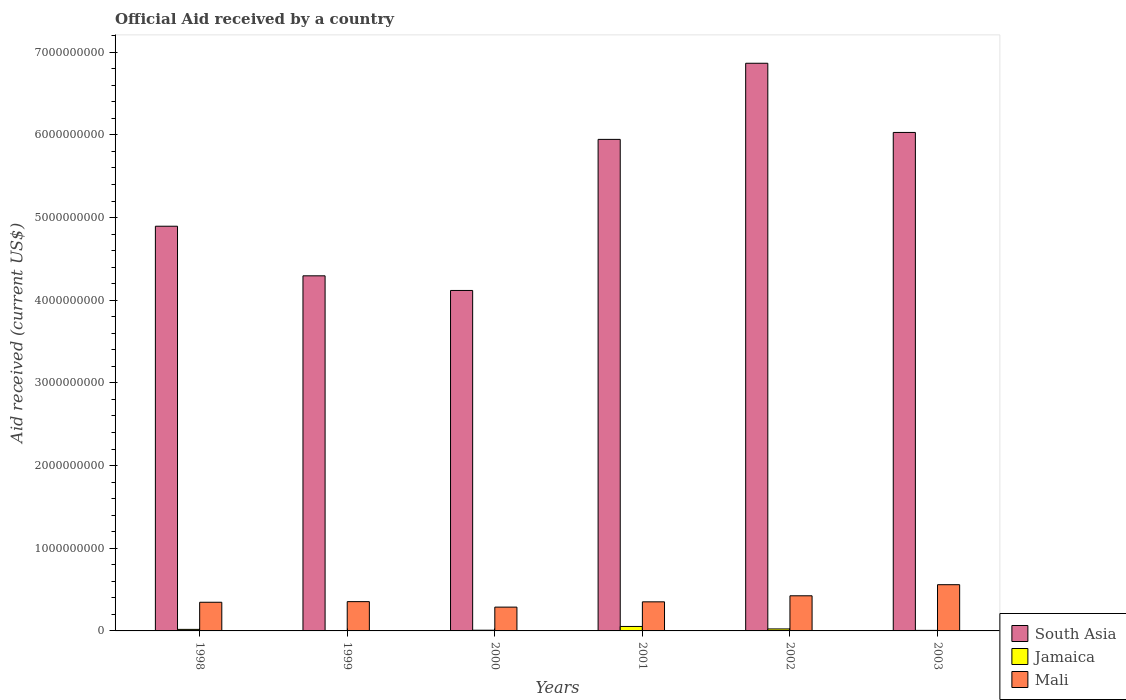How many different coloured bars are there?
Offer a very short reply. 3. Are the number of bars per tick equal to the number of legend labels?
Offer a terse response. No. Are the number of bars on each tick of the X-axis equal?
Provide a succinct answer. No. What is the net official aid received in Jamaica in 2003?
Your response must be concise. 6.52e+06. Across all years, what is the maximum net official aid received in South Asia?
Provide a succinct answer. 6.87e+09. Across all years, what is the minimum net official aid received in Mali?
Make the answer very short. 2.88e+08. In which year was the net official aid received in Mali maximum?
Make the answer very short. 2003. What is the total net official aid received in Mali in the graph?
Ensure brevity in your answer.  2.32e+09. What is the difference between the net official aid received in Jamaica in 1998 and that in 2002?
Give a very brief answer. -5.45e+06. What is the difference between the net official aid received in Jamaica in 1998 and the net official aid received in South Asia in 2002?
Provide a short and direct response. -6.85e+09. What is the average net official aid received in South Asia per year?
Your answer should be very brief. 5.36e+09. In the year 2002, what is the difference between the net official aid received in Mali and net official aid received in Jamaica?
Ensure brevity in your answer.  4.01e+08. What is the ratio of the net official aid received in South Asia in 1998 to that in 1999?
Offer a very short reply. 1.14. Is the net official aid received in South Asia in 2001 less than that in 2002?
Ensure brevity in your answer.  Yes. What is the difference between the highest and the second highest net official aid received in South Asia?
Offer a terse response. 8.37e+08. What is the difference between the highest and the lowest net official aid received in South Asia?
Give a very brief answer. 2.75e+09. In how many years, is the net official aid received in South Asia greater than the average net official aid received in South Asia taken over all years?
Ensure brevity in your answer.  3. Are the values on the major ticks of Y-axis written in scientific E-notation?
Give a very brief answer. No. Does the graph contain any zero values?
Make the answer very short. Yes. Does the graph contain grids?
Make the answer very short. No. What is the title of the graph?
Provide a short and direct response. Official Aid received by a country. Does "Equatorial Guinea" appear as one of the legend labels in the graph?
Offer a very short reply. No. What is the label or title of the X-axis?
Provide a succinct answer. Years. What is the label or title of the Y-axis?
Provide a short and direct response. Aid received (current US$). What is the Aid received (current US$) of South Asia in 1998?
Make the answer very short. 4.89e+09. What is the Aid received (current US$) of Jamaica in 1998?
Ensure brevity in your answer.  1.86e+07. What is the Aid received (current US$) in Mali in 1998?
Your answer should be very brief. 3.47e+08. What is the Aid received (current US$) of South Asia in 1999?
Provide a short and direct response. 4.30e+09. What is the Aid received (current US$) of Mali in 1999?
Your answer should be compact. 3.54e+08. What is the Aid received (current US$) of South Asia in 2000?
Ensure brevity in your answer.  4.12e+09. What is the Aid received (current US$) in Jamaica in 2000?
Your answer should be compact. 8.56e+06. What is the Aid received (current US$) in Mali in 2000?
Provide a succinct answer. 2.88e+08. What is the Aid received (current US$) of South Asia in 2001?
Provide a short and direct response. 5.95e+09. What is the Aid received (current US$) of Jamaica in 2001?
Offer a very short reply. 5.40e+07. What is the Aid received (current US$) of Mali in 2001?
Offer a very short reply. 3.52e+08. What is the Aid received (current US$) in South Asia in 2002?
Provide a short and direct response. 6.87e+09. What is the Aid received (current US$) in Jamaica in 2002?
Offer a terse response. 2.40e+07. What is the Aid received (current US$) of Mali in 2002?
Provide a succinct answer. 4.25e+08. What is the Aid received (current US$) of South Asia in 2003?
Ensure brevity in your answer.  6.03e+09. What is the Aid received (current US$) of Jamaica in 2003?
Your answer should be very brief. 6.52e+06. What is the Aid received (current US$) of Mali in 2003?
Ensure brevity in your answer.  5.59e+08. Across all years, what is the maximum Aid received (current US$) of South Asia?
Keep it short and to the point. 6.87e+09. Across all years, what is the maximum Aid received (current US$) of Jamaica?
Ensure brevity in your answer.  5.40e+07. Across all years, what is the maximum Aid received (current US$) in Mali?
Offer a very short reply. 5.59e+08. Across all years, what is the minimum Aid received (current US$) in South Asia?
Offer a very short reply. 4.12e+09. Across all years, what is the minimum Aid received (current US$) of Mali?
Your response must be concise. 2.88e+08. What is the total Aid received (current US$) in South Asia in the graph?
Make the answer very short. 3.21e+1. What is the total Aid received (current US$) in Jamaica in the graph?
Keep it short and to the point. 1.12e+08. What is the total Aid received (current US$) of Mali in the graph?
Your response must be concise. 2.32e+09. What is the difference between the Aid received (current US$) of South Asia in 1998 and that in 1999?
Provide a short and direct response. 6.00e+08. What is the difference between the Aid received (current US$) in Mali in 1998 and that in 1999?
Offer a very short reply. -7.57e+06. What is the difference between the Aid received (current US$) of South Asia in 1998 and that in 2000?
Give a very brief answer. 7.77e+08. What is the difference between the Aid received (current US$) in Jamaica in 1998 and that in 2000?
Ensure brevity in your answer.  1.00e+07. What is the difference between the Aid received (current US$) of Mali in 1998 and that in 2000?
Offer a very short reply. 5.87e+07. What is the difference between the Aid received (current US$) in South Asia in 1998 and that in 2001?
Give a very brief answer. -1.05e+09. What is the difference between the Aid received (current US$) in Jamaica in 1998 and that in 2001?
Provide a succinct answer. -3.54e+07. What is the difference between the Aid received (current US$) of Mali in 1998 and that in 2001?
Offer a terse response. -5.11e+06. What is the difference between the Aid received (current US$) in South Asia in 1998 and that in 2002?
Offer a terse response. -1.97e+09. What is the difference between the Aid received (current US$) of Jamaica in 1998 and that in 2002?
Keep it short and to the point. -5.45e+06. What is the difference between the Aid received (current US$) of Mali in 1998 and that in 2002?
Make the answer very short. -7.83e+07. What is the difference between the Aid received (current US$) of South Asia in 1998 and that in 2003?
Provide a short and direct response. -1.13e+09. What is the difference between the Aid received (current US$) of Jamaica in 1998 and that in 2003?
Keep it short and to the point. 1.20e+07. What is the difference between the Aid received (current US$) of Mali in 1998 and that in 2003?
Your answer should be very brief. -2.12e+08. What is the difference between the Aid received (current US$) of South Asia in 1999 and that in 2000?
Offer a terse response. 1.77e+08. What is the difference between the Aid received (current US$) in Mali in 1999 and that in 2000?
Provide a short and direct response. 6.63e+07. What is the difference between the Aid received (current US$) in South Asia in 1999 and that in 2001?
Your answer should be very brief. -1.65e+09. What is the difference between the Aid received (current US$) of Mali in 1999 and that in 2001?
Provide a short and direct response. 2.46e+06. What is the difference between the Aid received (current US$) of South Asia in 1999 and that in 2002?
Offer a terse response. -2.57e+09. What is the difference between the Aid received (current US$) in Mali in 1999 and that in 2002?
Your response must be concise. -7.07e+07. What is the difference between the Aid received (current US$) of South Asia in 1999 and that in 2003?
Provide a short and direct response. -1.73e+09. What is the difference between the Aid received (current US$) of Mali in 1999 and that in 2003?
Ensure brevity in your answer.  -2.05e+08. What is the difference between the Aid received (current US$) of South Asia in 2000 and that in 2001?
Your answer should be very brief. -1.83e+09. What is the difference between the Aid received (current US$) of Jamaica in 2000 and that in 2001?
Your answer should be compact. -4.54e+07. What is the difference between the Aid received (current US$) in Mali in 2000 and that in 2001?
Provide a succinct answer. -6.38e+07. What is the difference between the Aid received (current US$) in South Asia in 2000 and that in 2002?
Give a very brief answer. -2.75e+09. What is the difference between the Aid received (current US$) in Jamaica in 2000 and that in 2002?
Make the answer very short. -1.55e+07. What is the difference between the Aid received (current US$) in Mali in 2000 and that in 2002?
Keep it short and to the point. -1.37e+08. What is the difference between the Aid received (current US$) in South Asia in 2000 and that in 2003?
Make the answer very short. -1.91e+09. What is the difference between the Aid received (current US$) in Jamaica in 2000 and that in 2003?
Your response must be concise. 2.04e+06. What is the difference between the Aid received (current US$) of Mali in 2000 and that in 2003?
Offer a very short reply. -2.71e+08. What is the difference between the Aid received (current US$) of South Asia in 2001 and that in 2002?
Keep it short and to the point. -9.21e+08. What is the difference between the Aid received (current US$) in Jamaica in 2001 and that in 2002?
Your response must be concise. 3.00e+07. What is the difference between the Aid received (current US$) in Mali in 2001 and that in 2002?
Provide a succinct answer. -7.32e+07. What is the difference between the Aid received (current US$) of South Asia in 2001 and that in 2003?
Provide a succinct answer. -8.39e+07. What is the difference between the Aid received (current US$) of Jamaica in 2001 and that in 2003?
Offer a very short reply. 4.75e+07. What is the difference between the Aid received (current US$) in Mali in 2001 and that in 2003?
Your answer should be very brief. -2.07e+08. What is the difference between the Aid received (current US$) in South Asia in 2002 and that in 2003?
Offer a very short reply. 8.37e+08. What is the difference between the Aid received (current US$) in Jamaica in 2002 and that in 2003?
Offer a terse response. 1.75e+07. What is the difference between the Aid received (current US$) in Mali in 2002 and that in 2003?
Your answer should be very brief. -1.34e+08. What is the difference between the Aid received (current US$) in South Asia in 1998 and the Aid received (current US$) in Mali in 1999?
Offer a terse response. 4.54e+09. What is the difference between the Aid received (current US$) of Jamaica in 1998 and the Aid received (current US$) of Mali in 1999?
Make the answer very short. -3.36e+08. What is the difference between the Aid received (current US$) in South Asia in 1998 and the Aid received (current US$) in Jamaica in 2000?
Make the answer very short. 4.89e+09. What is the difference between the Aid received (current US$) in South Asia in 1998 and the Aid received (current US$) in Mali in 2000?
Your response must be concise. 4.61e+09. What is the difference between the Aid received (current US$) in Jamaica in 1998 and the Aid received (current US$) in Mali in 2000?
Ensure brevity in your answer.  -2.69e+08. What is the difference between the Aid received (current US$) in South Asia in 1998 and the Aid received (current US$) in Jamaica in 2001?
Offer a very short reply. 4.84e+09. What is the difference between the Aid received (current US$) of South Asia in 1998 and the Aid received (current US$) of Mali in 2001?
Your answer should be very brief. 4.54e+09. What is the difference between the Aid received (current US$) of Jamaica in 1998 and the Aid received (current US$) of Mali in 2001?
Your answer should be very brief. -3.33e+08. What is the difference between the Aid received (current US$) of South Asia in 1998 and the Aid received (current US$) of Jamaica in 2002?
Your answer should be compact. 4.87e+09. What is the difference between the Aid received (current US$) in South Asia in 1998 and the Aid received (current US$) in Mali in 2002?
Your answer should be compact. 4.47e+09. What is the difference between the Aid received (current US$) of Jamaica in 1998 and the Aid received (current US$) of Mali in 2002?
Give a very brief answer. -4.06e+08. What is the difference between the Aid received (current US$) of South Asia in 1998 and the Aid received (current US$) of Jamaica in 2003?
Give a very brief answer. 4.89e+09. What is the difference between the Aid received (current US$) of South Asia in 1998 and the Aid received (current US$) of Mali in 2003?
Make the answer very short. 4.34e+09. What is the difference between the Aid received (current US$) of Jamaica in 1998 and the Aid received (current US$) of Mali in 2003?
Give a very brief answer. -5.41e+08. What is the difference between the Aid received (current US$) in South Asia in 1999 and the Aid received (current US$) in Jamaica in 2000?
Your answer should be compact. 4.29e+09. What is the difference between the Aid received (current US$) of South Asia in 1999 and the Aid received (current US$) of Mali in 2000?
Provide a succinct answer. 4.01e+09. What is the difference between the Aid received (current US$) in South Asia in 1999 and the Aid received (current US$) in Jamaica in 2001?
Make the answer very short. 4.24e+09. What is the difference between the Aid received (current US$) in South Asia in 1999 and the Aid received (current US$) in Mali in 2001?
Your answer should be compact. 3.94e+09. What is the difference between the Aid received (current US$) of South Asia in 1999 and the Aid received (current US$) of Jamaica in 2002?
Your answer should be very brief. 4.27e+09. What is the difference between the Aid received (current US$) of South Asia in 1999 and the Aid received (current US$) of Mali in 2002?
Give a very brief answer. 3.87e+09. What is the difference between the Aid received (current US$) of South Asia in 1999 and the Aid received (current US$) of Jamaica in 2003?
Keep it short and to the point. 4.29e+09. What is the difference between the Aid received (current US$) in South Asia in 1999 and the Aid received (current US$) in Mali in 2003?
Offer a terse response. 3.74e+09. What is the difference between the Aid received (current US$) in South Asia in 2000 and the Aid received (current US$) in Jamaica in 2001?
Provide a succinct answer. 4.06e+09. What is the difference between the Aid received (current US$) of South Asia in 2000 and the Aid received (current US$) of Mali in 2001?
Your response must be concise. 3.77e+09. What is the difference between the Aid received (current US$) in Jamaica in 2000 and the Aid received (current US$) in Mali in 2001?
Give a very brief answer. -3.43e+08. What is the difference between the Aid received (current US$) of South Asia in 2000 and the Aid received (current US$) of Jamaica in 2002?
Provide a short and direct response. 4.09e+09. What is the difference between the Aid received (current US$) in South Asia in 2000 and the Aid received (current US$) in Mali in 2002?
Provide a succinct answer. 3.69e+09. What is the difference between the Aid received (current US$) of Jamaica in 2000 and the Aid received (current US$) of Mali in 2002?
Offer a terse response. -4.16e+08. What is the difference between the Aid received (current US$) in South Asia in 2000 and the Aid received (current US$) in Jamaica in 2003?
Your answer should be very brief. 4.11e+09. What is the difference between the Aid received (current US$) of South Asia in 2000 and the Aid received (current US$) of Mali in 2003?
Offer a terse response. 3.56e+09. What is the difference between the Aid received (current US$) in Jamaica in 2000 and the Aid received (current US$) in Mali in 2003?
Ensure brevity in your answer.  -5.51e+08. What is the difference between the Aid received (current US$) of South Asia in 2001 and the Aid received (current US$) of Jamaica in 2002?
Offer a terse response. 5.92e+09. What is the difference between the Aid received (current US$) of South Asia in 2001 and the Aid received (current US$) of Mali in 2002?
Give a very brief answer. 5.52e+09. What is the difference between the Aid received (current US$) of Jamaica in 2001 and the Aid received (current US$) of Mali in 2002?
Keep it short and to the point. -3.71e+08. What is the difference between the Aid received (current US$) in South Asia in 2001 and the Aid received (current US$) in Jamaica in 2003?
Make the answer very short. 5.94e+09. What is the difference between the Aid received (current US$) in South Asia in 2001 and the Aid received (current US$) in Mali in 2003?
Offer a terse response. 5.39e+09. What is the difference between the Aid received (current US$) in Jamaica in 2001 and the Aid received (current US$) in Mali in 2003?
Your response must be concise. -5.05e+08. What is the difference between the Aid received (current US$) in South Asia in 2002 and the Aid received (current US$) in Jamaica in 2003?
Your response must be concise. 6.86e+09. What is the difference between the Aid received (current US$) in South Asia in 2002 and the Aid received (current US$) in Mali in 2003?
Offer a terse response. 6.31e+09. What is the difference between the Aid received (current US$) of Jamaica in 2002 and the Aid received (current US$) of Mali in 2003?
Ensure brevity in your answer.  -5.35e+08. What is the average Aid received (current US$) of South Asia per year?
Ensure brevity in your answer.  5.36e+09. What is the average Aid received (current US$) of Jamaica per year?
Your answer should be very brief. 1.86e+07. What is the average Aid received (current US$) of Mali per year?
Keep it short and to the point. 3.87e+08. In the year 1998, what is the difference between the Aid received (current US$) in South Asia and Aid received (current US$) in Jamaica?
Offer a terse response. 4.88e+09. In the year 1998, what is the difference between the Aid received (current US$) of South Asia and Aid received (current US$) of Mali?
Offer a very short reply. 4.55e+09. In the year 1998, what is the difference between the Aid received (current US$) in Jamaica and Aid received (current US$) in Mali?
Your answer should be compact. -3.28e+08. In the year 1999, what is the difference between the Aid received (current US$) of South Asia and Aid received (current US$) of Mali?
Offer a very short reply. 3.94e+09. In the year 2000, what is the difference between the Aid received (current US$) in South Asia and Aid received (current US$) in Jamaica?
Your answer should be very brief. 4.11e+09. In the year 2000, what is the difference between the Aid received (current US$) in South Asia and Aid received (current US$) in Mali?
Offer a very short reply. 3.83e+09. In the year 2000, what is the difference between the Aid received (current US$) of Jamaica and Aid received (current US$) of Mali?
Provide a succinct answer. -2.79e+08. In the year 2001, what is the difference between the Aid received (current US$) in South Asia and Aid received (current US$) in Jamaica?
Provide a short and direct response. 5.89e+09. In the year 2001, what is the difference between the Aid received (current US$) of South Asia and Aid received (current US$) of Mali?
Offer a terse response. 5.59e+09. In the year 2001, what is the difference between the Aid received (current US$) of Jamaica and Aid received (current US$) of Mali?
Your answer should be very brief. -2.98e+08. In the year 2002, what is the difference between the Aid received (current US$) in South Asia and Aid received (current US$) in Jamaica?
Your answer should be compact. 6.84e+09. In the year 2002, what is the difference between the Aid received (current US$) of South Asia and Aid received (current US$) of Mali?
Your answer should be compact. 6.44e+09. In the year 2002, what is the difference between the Aid received (current US$) in Jamaica and Aid received (current US$) in Mali?
Make the answer very short. -4.01e+08. In the year 2003, what is the difference between the Aid received (current US$) of South Asia and Aid received (current US$) of Jamaica?
Your answer should be compact. 6.02e+09. In the year 2003, what is the difference between the Aid received (current US$) in South Asia and Aid received (current US$) in Mali?
Provide a succinct answer. 5.47e+09. In the year 2003, what is the difference between the Aid received (current US$) of Jamaica and Aid received (current US$) of Mali?
Offer a terse response. -5.53e+08. What is the ratio of the Aid received (current US$) of South Asia in 1998 to that in 1999?
Your response must be concise. 1.14. What is the ratio of the Aid received (current US$) in Mali in 1998 to that in 1999?
Offer a very short reply. 0.98. What is the ratio of the Aid received (current US$) of South Asia in 1998 to that in 2000?
Make the answer very short. 1.19. What is the ratio of the Aid received (current US$) of Jamaica in 1998 to that in 2000?
Your answer should be compact. 2.17. What is the ratio of the Aid received (current US$) of Mali in 1998 to that in 2000?
Offer a terse response. 1.2. What is the ratio of the Aid received (current US$) of South Asia in 1998 to that in 2001?
Your answer should be very brief. 0.82. What is the ratio of the Aid received (current US$) in Jamaica in 1998 to that in 2001?
Keep it short and to the point. 0.34. What is the ratio of the Aid received (current US$) of Mali in 1998 to that in 2001?
Keep it short and to the point. 0.99. What is the ratio of the Aid received (current US$) of South Asia in 1998 to that in 2002?
Provide a succinct answer. 0.71. What is the ratio of the Aid received (current US$) of Jamaica in 1998 to that in 2002?
Give a very brief answer. 0.77. What is the ratio of the Aid received (current US$) of Mali in 1998 to that in 2002?
Make the answer very short. 0.82. What is the ratio of the Aid received (current US$) of South Asia in 1998 to that in 2003?
Ensure brevity in your answer.  0.81. What is the ratio of the Aid received (current US$) in Jamaica in 1998 to that in 2003?
Provide a short and direct response. 2.85. What is the ratio of the Aid received (current US$) in Mali in 1998 to that in 2003?
Your response must be concise. 0.62. What is the ratio of the Aid received (current US$) of South Asia in 1999 to that in 2000?
Make the answer very short. 1.04. What is the ratio of the Aid received (current US$) of Mali in 1999 to that in 2000?
Your response must be concise. 1.23. What is the ratio of the Aid received (current US$) in South Asia in 1999 to that in 2001?
Give a very brief answer. 0.72. What is the ratio of the Aid received (current US$) of South Asia in 1999 to that in 2002?
Offer a very short reply. 0.63. What is the ratio of the Aid received (current US$) of Mali in 1999 to that in 2002?
Provide a succinct answer. 0.83. What is the ratio of the Aid received (current US$) in South Asia in 1999 to that in 2003?
Ensure brevity in your answer.  0.71. What is the ratio of the Aid received (current US$) of Mali in 1999 to that in 2003?
Your answer should be compact. 0.63. What is the ratio of the Aid received (current US$) of South Asia in 2000 to that in 2001?
Your answer should be very brief. 0.69. What is the ratio of the Aid received (current US$) in Jamaica in 2000 to that in 2001?
Make the answer very short. 0.16. What is the ratio of the Aid received (current US$) of Mali in 2000 to that in 2001?
Offer a very short reply. 0.82. What is the ratio of the Aid received (current US$) of South Asia in 2000 to that in 2002?
Offer a very short reply. 0.6. What is the ratio of the Aid received (current US$) of Jamaica in 2000 to that in 2002?
Ensure brevity in your answer.  0.36. What is the ratio of the Aid received (current US$) of Mali in 2000 to that in 2002?
Make the answer very short. 0.68. What is the ratio of the Aid received (current US$) in South Asia in 2000 to that in 2003?
Offer a very short reply. 0.68. What is the ratio of the Aid received (current US$) of Jamaica in 2000 to that in 2003?
Provide a short and direct response. 1.31. What is the ratio of the Aid received (current US$) of Mali in 2000 to that in 2003?
Make the answer very short. 0.52. What is the ratio of the Aid received (current US$) in South Asia in 2001 to that in 2002?
Make the answer very short. 0.87. What is the ratio of the Aid received (current US$) of Jamaica in 2001 to that in 2002?
Make the answer very short. 2.25. What is the ratio of the Aid received (current US$) of Mali in 2001 to that in 2002?
Provide a succinct answer. 0.83. What is the ratio of the Aid received (current US$) in South Asia in 2001 to that in 2003?
Offer a terse response. 0.99. What is the ratio of the Aid received (current US$) in Jamaica in 2001 to that in 2003?
Give a very brief answer. 8.28. What is the ratio of the Aid received (current US$) in Mali in 2001 to that in 2003?
Provide a short and direct response. 0.63. What is the ratio of the Aid received (current US$) of South Asia in 2002 to that in 2003?
Make the answer very short. 1.14. What is the ratio of the Aid received (current US$) in Jamaica in 2002 to that in 2003?
Provide a short and direct response. 3.68. What is the ratio of the Aid received (current US$) of Mali in 2002 to that in 2003?
Make the answer very short. 0.76. What is the difference between the highest and the second highest Aid received (current US$) of South Asia?
Offer a very short reply. 8.37e+08. What is the difference between the highest and the second highest Aid received (current US$) of Jamaica?
Give a very brief answer. 3.00e+07. What is the difference between the highest and the second highest Aid received (current US$) in Mali?
Your answer should be compact. 1.34e+08. What is the difference between the highest and the lowest Aid received (current US$) in South Asia?
Your answer should be compact. 2.75e+09. What is the difference between the highest and the lowest Aid received (current US$) of Jamaica?
Keep it short and to the point. 5.40e+07. What is the difference between the highest and the lowest Aid received (current US$) in Mali?
Make the answer very short. 2.71e+08. 